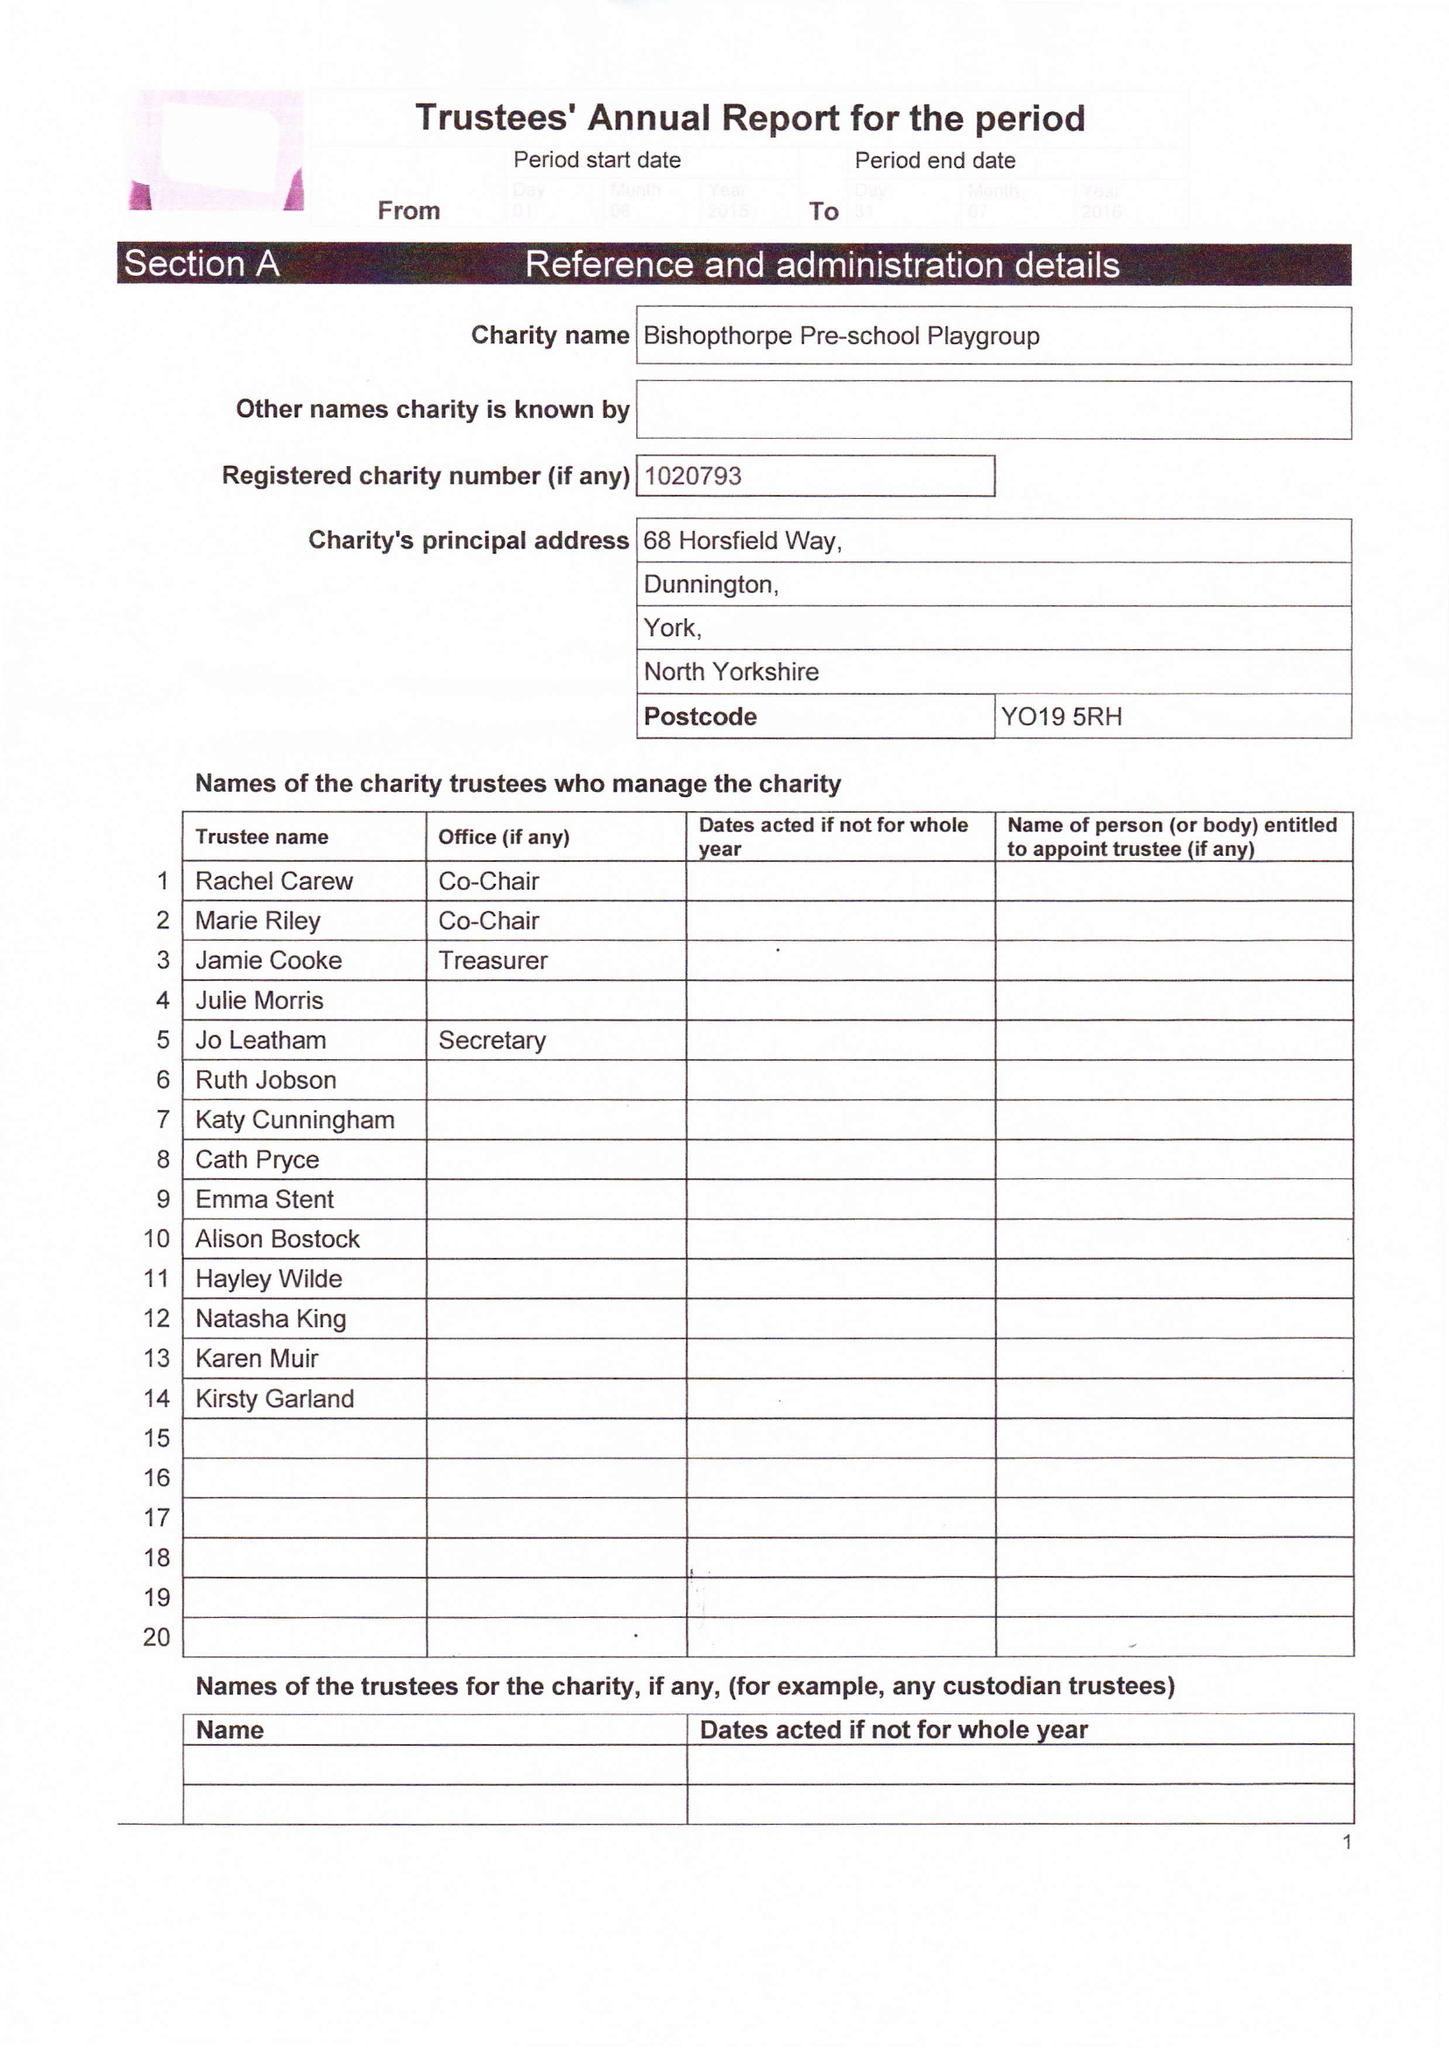What is the value for the income_annually_in_british_pounds?
Answer the question using a single word or phrase. 75658.00 